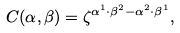<formula> <loc_0><loc_0><loc_500><loc_500>C ( \alpha , \beta ) = \zeta ^ { \alpha ^ { 1 } \cdot \beta ^ { 2 } - \alpha ^ { 2 } \cdot \beta ^ { 1 } } ,</formula> 